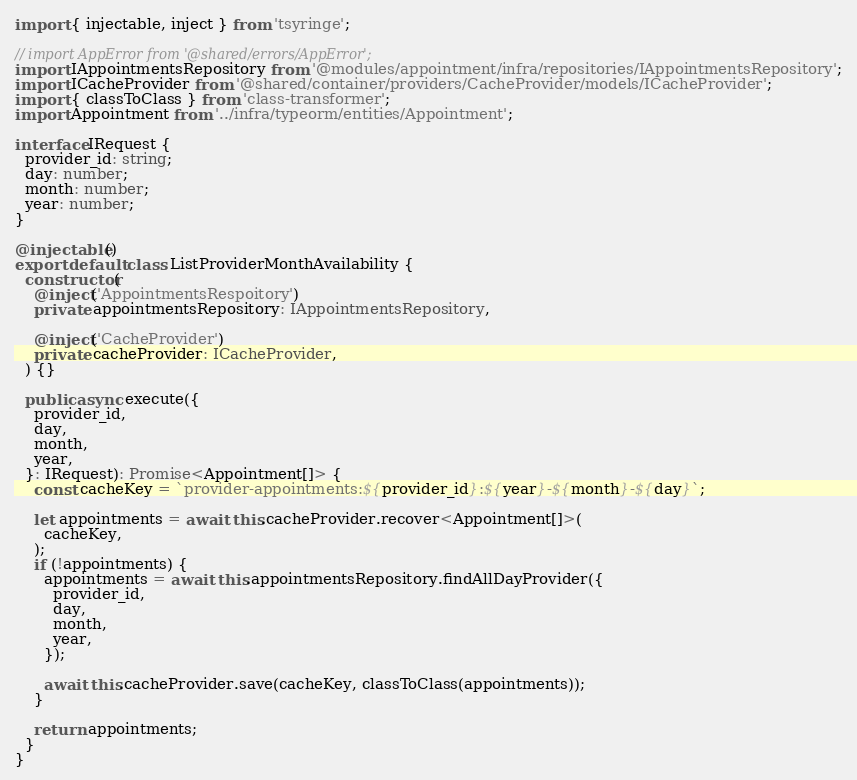<code> <loc_0><loc_0><loc_500><loc_500><_TypeScript_>import { injectable, inject } from 'tsyringe';

// import AppError from '@shared/errors/AppError';
import IAppointmentsRepository from '@modules/appointment/infra/repositories/IAppointmentsRepository';
import ICacheProvider from '@shared/container/providers/CacheProvider/models/ICacheProvider';
import { classToClass } from 'class-transformer';
import Appointment from '../infra/typeorm/entities/Appointment';

interface IRequest {
  provider_id: string;
  day: number;
  month: number;
  year: number;
}

@injectable()
export default class ListProviderMonthAvailability {
  constructor(
    @inject('AppointmentsRespoitory')
    private appointmentsRepository: IAppointmentsRepository,

    @inject('CacheProvider')
    private cacheProvider: ICacheProvider,
  ) {}

  public async execute({
    provider_id,
    day,
    month,
    year,
  }: IRequest): Promise<Appointment[]> {
    const cacheKey = `provider-appointments:${provider_id}:${year}-${month}-${day}`;

    let appointments = await this.cacheProvider.recover<Appointment[]>(
      cacheKey,
    );
    if (!appointments) {
      appointments = await this.appointmentsRepository.findAllDayProvider({
        provider_id,
        day,
        month,
        year,
      });

      await this.cacheProvider.save(cacheKey, classToClass(appointments));
    }

    return appointments;
  }
}
</code> 